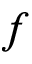<formula> <loc_0><loc_0><loc_500><loc_500>f</formula> 